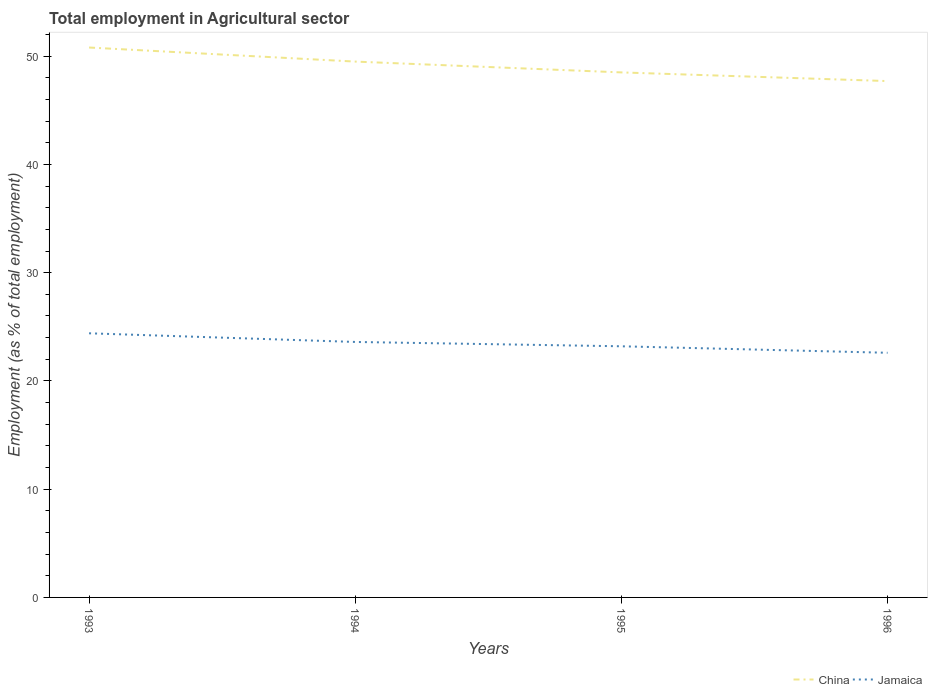How many different coloured lines are there?
Offer a terse response. 2. Does the line corresponding to China intersect with the line corresponding to Jamaica?
Keep it short and to the point. No. Is the number of lines equal to the number of legend labels?
Provide a succinct answer. Yes. Across all years, what is the maximum employment in agricultural sector in Jamaica?
Your answer should be compact. 22.6. What is the total employment in agricultural sector in China in the graph?
Provide a succinct answer. 1.8. What is the difference between the highest and the second highest employment in agricultural sector in China?
Give a very brief answer. 3.1. Is the employment in agricultural sector in Jamaica strictly greater than the employment in agricultural sector in China over the years?
Keep it short and to the point. Yes. How many lines are there?
Keep it short and to the point. 2. How many years are there in the graph?
Ensure brevity in your answer.  4. What is the difference between two consecutive major ticks on the Y-axis?
Your answer should be very brief. 10. Are the values on the major ticks of Y-axis written in scientific E-notation?
Make the answer very short. No. Does the graph contain grids?
Provide a succinct answer. No. How are the legend labels stacked?
Offer a very short reply. Horizontal. What is the title of the graph?
Give a very brief answer. Total employment in Agricultural sector. Does "Ireland" appear as one of the legend labels in the graph?
Give a very brief answer. No. What is the label or title of the Y-axis?
Provide a short and direct response. Employment (as % of total employment). What is the Employment (as % of total employment) in China in 1993?
Make the answer very short. 50.8. What is the Employment (as % of total employment) of Jamaica in 1993?
Provide a succinct answer. 24.4. What is the Employment (as % of total employment) of China in 1994?
Your answer should be compact. 49.5. What is the Employment (as % of total employment) in Jamaica in 1994?
Give a very brief answer. 23.6. What is the Employment (as % of total employment) of China in 1995?
Provide a short and direct response. 48.5. What is the Employment (as % of total employment) of Jamaica in 1995?
Give a very brief answer. 23.2. What is the Employment (as % of total employment) of China in 1996?
Provide a succinct answer. 47.7. What is the Employment (as % of total employment) of Jamaica in 1996?
Provide a short and direct response. 22.6. Across all years, what is the maximum Employment (as % of total employment) in China?
Your answer should be very brief. 50.8. Across all years, what is the maximum Employment (as % of total employment) in Jamaica?
Your answer should be very brief. 24.4. Across all years, what is the minimum Employment (as % of total employment) in China?
Your response must be concise. 47.7. Across all years, what is the minimum Employment (as % of total employment) in Jamaica?
Offer a terse response. 22.6. What is the total Employment (as % of total employment) of China in the graph?
Ensure brevity in your answer.  196.5. What is the total Employment (as % of total employment) of Jamaica in the graph?
Your answer should be very brief. 93.8. What is the difference between the Employment (as % of total employment) in China in 1993 and that in 1994?
Offer a very short reply. 1.3. What is the difference between the Employment (as % of total employment) in China in 1993 and that in 1995?
Offer a very short reply. 2.3. What is the difference between the Employment (as % of total employment) of Jamaica in 1993 and that in 1996?
Your answer should be very brief. 1.8. What is the difference between the Employment (as % of total employment) of China in 1995 and that in 1996?
Offer a very short reply. 0.8. What is the difference between the Employment (as % of total employment) in China in 1993 and the Employment (as % of total employment) in Jamaica in 1994?
Keep it short and to the point. 27.2. What is the difference between the Employment (as % of total employment) of China in 1993 and the Employment (as % of total employment) of Jamaica in 1995?
Your answer should be compact. 27.6. What is the difference between the Employment (as % of total employment) of China in 1993 and the Employment (as % of total employment) of Jamaica in 1996?
Make the answer very short. 28.2. What is the difference between the Employment (as % of total employment) in China in 1994 and the Employment (as % of total employment) in Jamaica in 1995?
Ensure brevity in your answer.  26.3. What is the difference between the Employment (as % of total employment) in China in 1994 and the Employment (as % of total employment) in Jamaica in 1996?
Provide a succinct answer. 26.9. What is the difference between the Employment (as % of total employment) in China in 1995 and the Employment (as % of total employment) in Jamaica in 1996?
Provide a short and direct response. 25.9. What is the average Employment (as % of total employment) of China per year?
Your answer should be compact. 49.12. What is the average Employment (as % of total employment) of Jamaica per year?
Your response must be concise. 23.45. In the year 1993, what is the difference between the Employment (as % of total employment) of China and Employment (as % of total employment) of Jamaica?
Ensure brevity in your answer.  26.4. In the year 1994, what is the difference between the Employment (as % of total employment) in China and Employment (as % of total employment) in Jamaica?
Provide a succinct answer. 25.9. In the year 1995, what is the difference between the Employment (as % of total employment) in China and Employment (as % of total employment) in Jamaica?
Offer a terse response. 25.3. In the year 1996, what is the difference between the Employment (as % of total employment) of China and Employment (as % of total employment) of Jamaica?
Your response must be concise. 25.1. What is the ratio of the Employment (as % of total employment) of China in 1993 to that in 1994?
Ensure brevity in your answer.  1.03. What is the ratio of the Employment (as % of total employment) in Jamaica in 1993 to that in 1994?
Ensure brevity in your answer.  1.03. What is the ratio of the Employment (as % of total employment) of China in 1993 to that in 1995?
Your response must be concise. 1.05. What is the ratio of the Employment (as % of total employment) of Jamaica in 1993 to that in 1995?
Make the answer very short. 1.05. What is the ratio of the Employment (as % of total employment) in China in 1993 to that in 1996?
Your answer should be very brief. 1.06. What is the ratio of the Employment (as % of total employment) in Jamaica in 1993 to that in 1996?
Offer a terse response. 1.08. What is the ratio of the Employment (as % of total employment) in China in 1994 to that in 1995?
Offer a terse response. 1.02. What is the ratio of the Employment (as % of total employment) of Jamaica in 1994 to that in 1995?
Your answer should be very brief. 1.02. What is the ratio of the Employment (as % of total employment) of China in 1994 to that in 1996?
Offer a very short reply. 1.04. What is the ratio of the Employment (as % of total employment) in Jamaica in 1994 to that in 1996?
Your answer should be very brief. 1.04. What is the ratio of the Employment (as % of total employment) of China in 1995 to that in 1996?
Offer a terse response. 1.02. What is the ratio of the Employment (as % of total employment) of Jamaica in 1995 to that in 1996?
Ensure brevity in your answer.  1.03. What is the difference between the highest and the second highest Employment (as % of total employment) of China?
Your response must be concise. 1.3. What is the difference between the highest and the lowest Employment (as % of total employment) in Jamaica?
Offer a terse response. 1.8. 